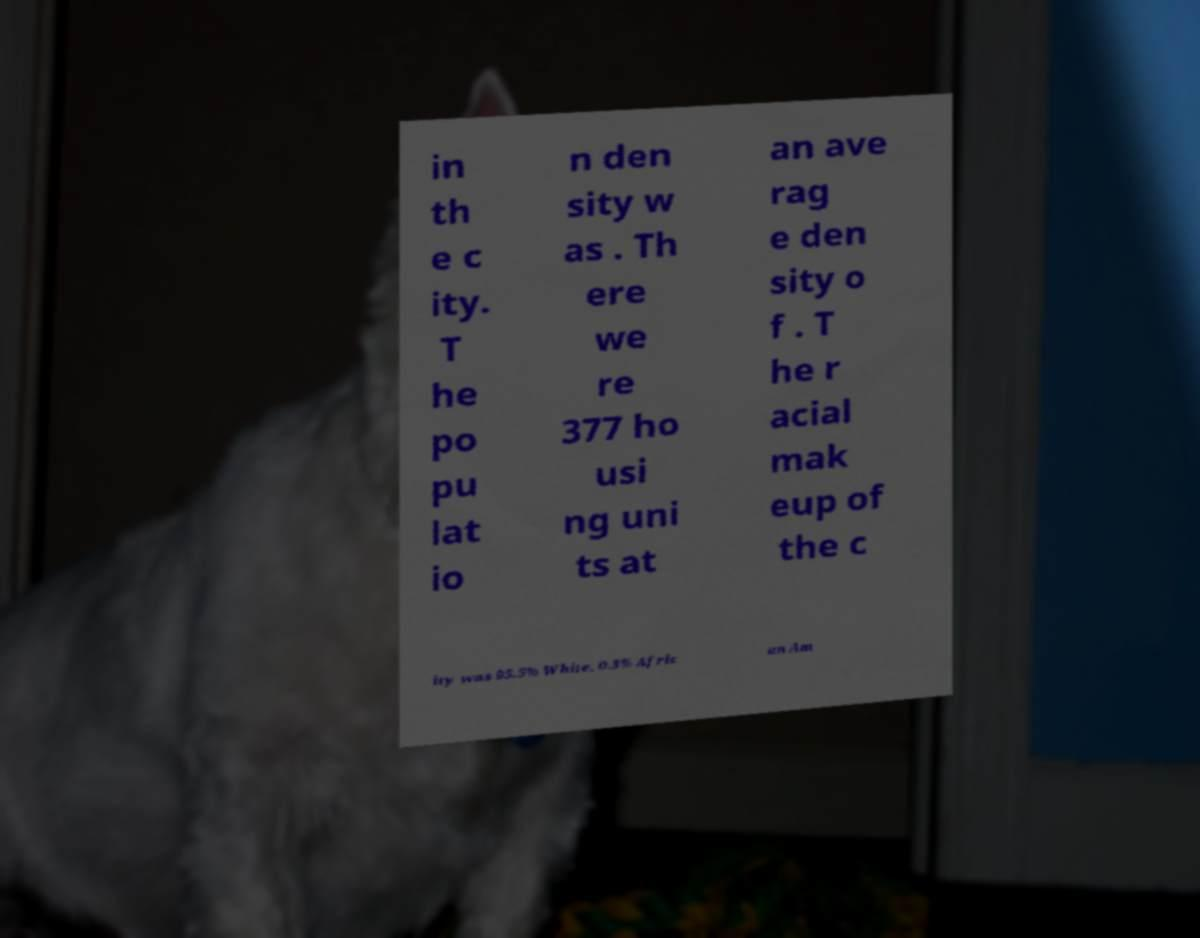For documentation purposes, I need the text within this image transcribed. Could you provide that? in th e c ity. T he po pu lat io n den sity w as . Th ere we re 377 ho usi ng uni ts at an ave rag e den sity o f . T he r acial mak eup of the c ity was 95.5% White, 0.3% Afric an Am 